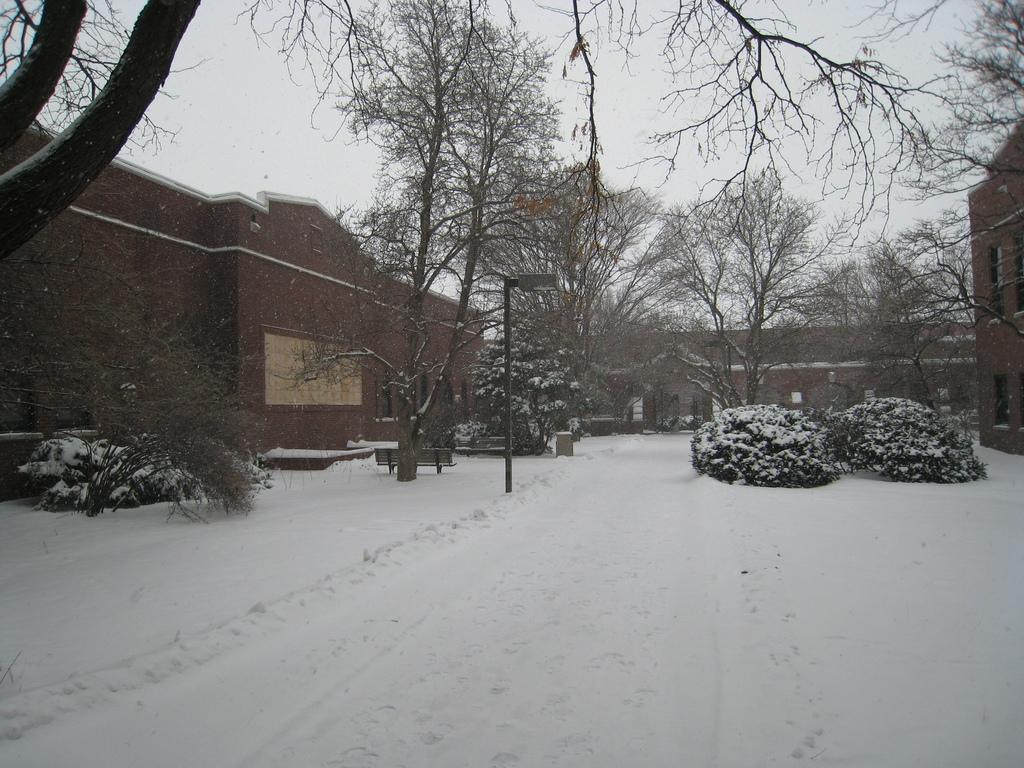What is the main feature in the foreground of the image? There is snow in the foreground of the image. What can be seen in the background of the image? There are trees, a pole, shrubs, buildings, and the sky visible in the background of the image. Are there any trees present at the top of the image? Yes, trees are present at the top of the facts. What type of list can be seen hanging from the pole in the image? There is no list present in the image; the pole is mentioned as a feature in the background, but no additional details are provided. How many rabbits are hopping through the snow in the image? There are no rabbits present in the image; the main feature in the foreground is snow, and no animals are mentioned in the facts. 